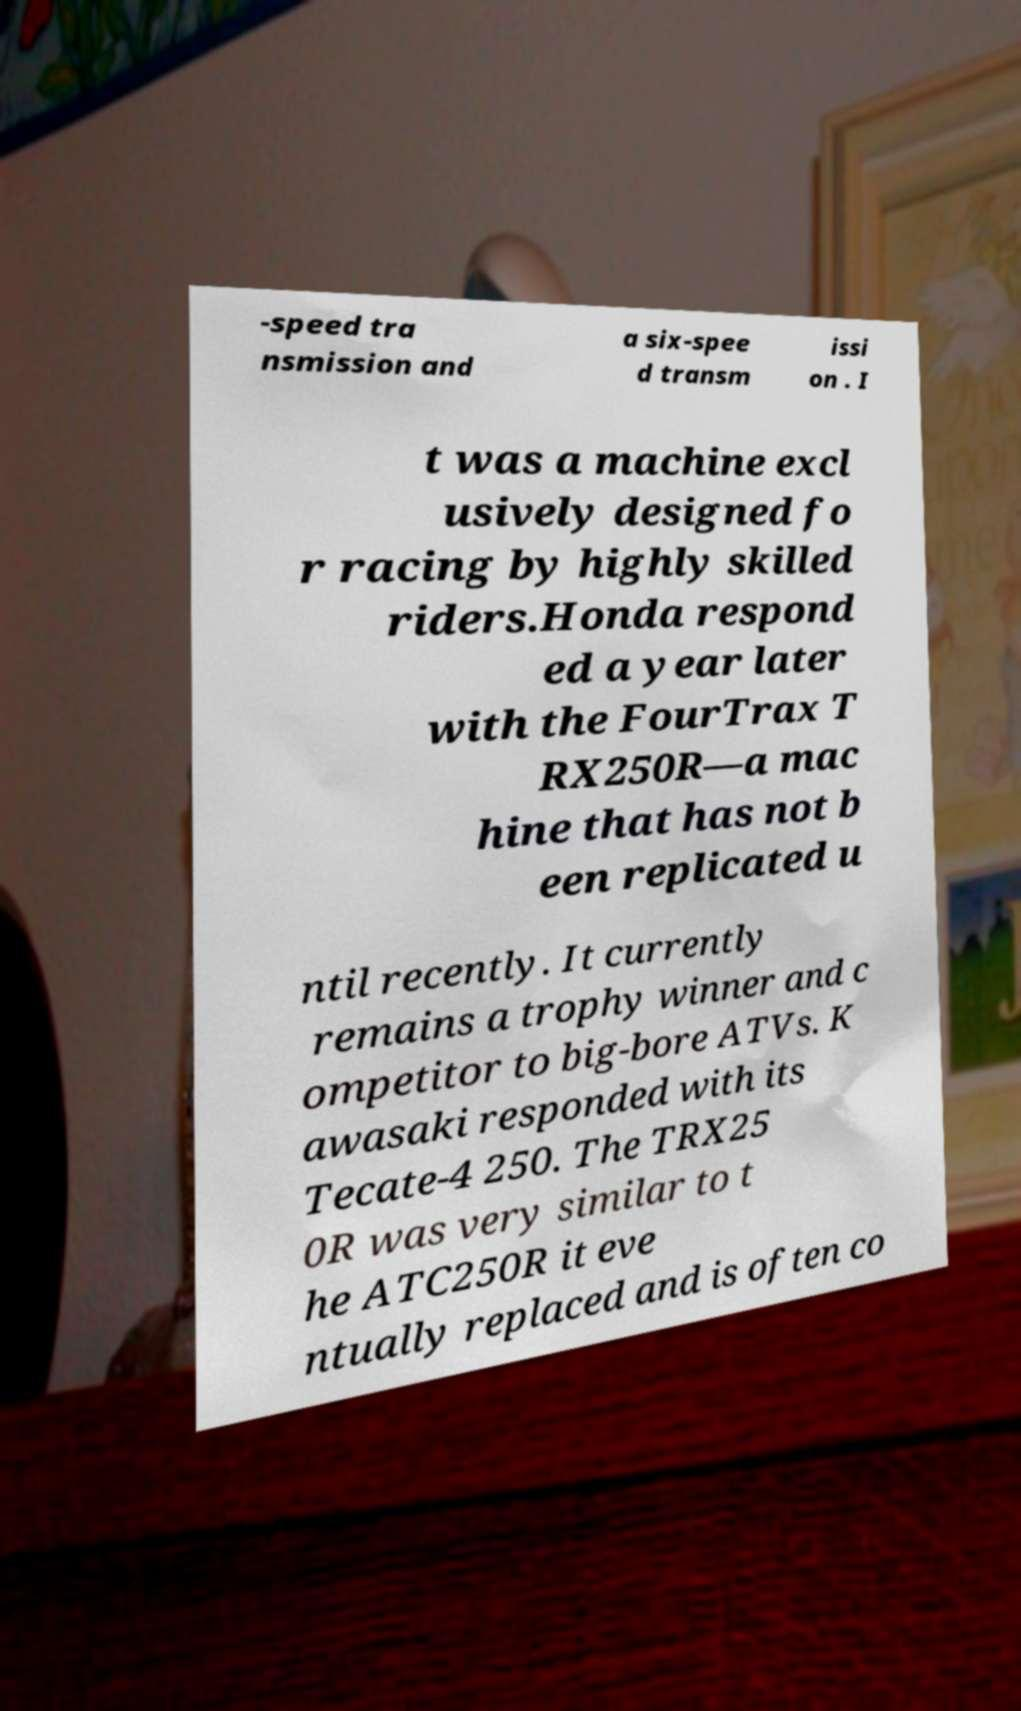Can you accurately transcribe the text from the provided image for me? -speed tra nsmission and a six-spee d transm issi on . I t was a machine excl usively designed fo r racing by highly skilled riders.Honda respond ed a year later with the FourTrax T RX250R—a mac hine that has not b een replicated u ntil recently. It currently remains a trophy winner and c ompetitor to big-bore ATVs. K awasaki responded with its Tecate-4 250. The TRX25 0R was very similar to t he ATC250R it eve ntually replaced and is often co 